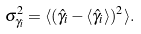<formula> <loc_0><loc_0><loc_500><loc_500>\sigma _ { \gamma _ { i } } ^ { 2 } = \langle ( \hat { \gamma } _ { i } - \langle \hat { \gamma } _ { i } \rangle ) ^ { 2 } \rangle .</formula> 